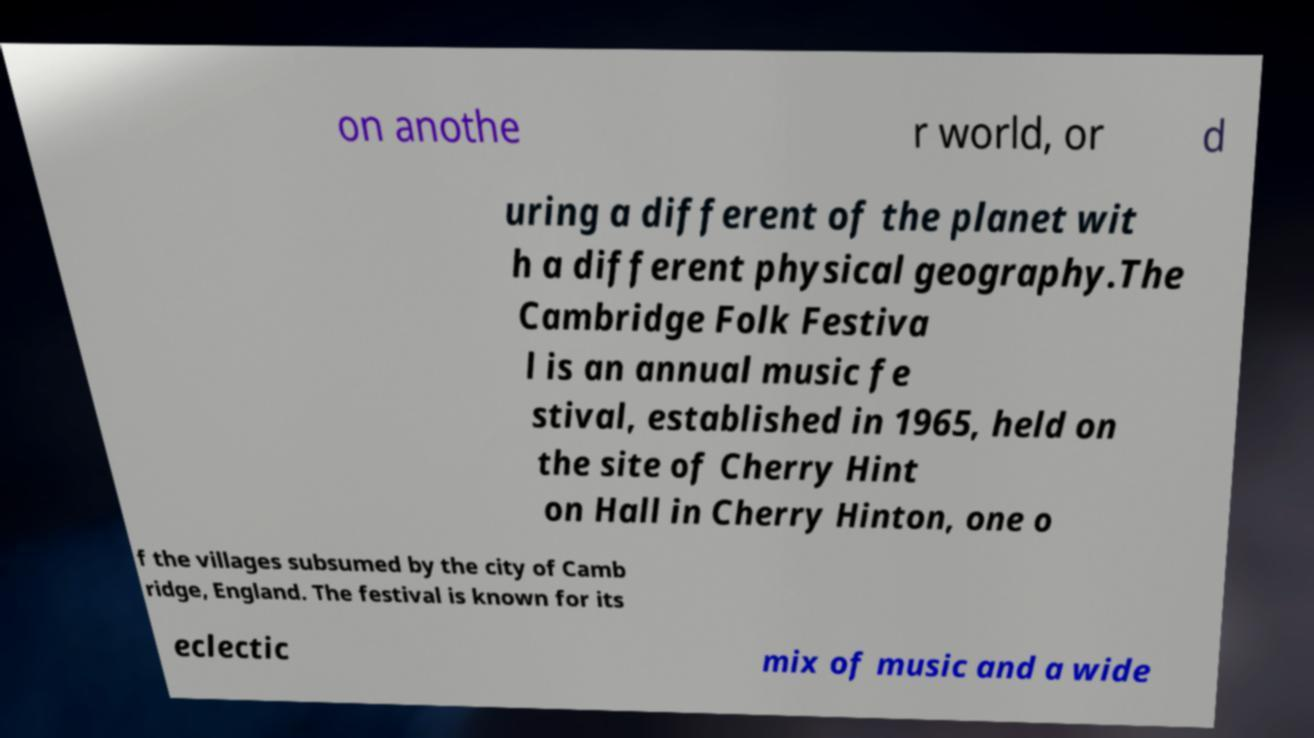Please read and relay the text visible in this image. What does it say? on anothe r world, or d uring a different of the planet wit h a different physical geography.The Cambridge Folk Festiva l is an annual music fe stival, established in 1965, held on the site of Cherry Hint on Hall in Cherry Hinton, one o f the villages subsumed by the city of Camb ridge, England. The festival is known for its eclectic mix of music and a wide 